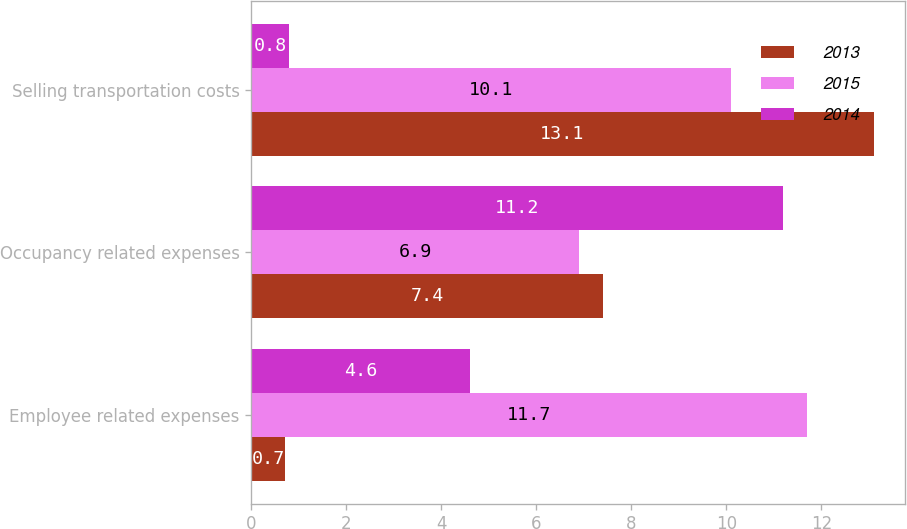Convert chart. <chart><loc_0><loc_0><loc_500><loc_500><stacked_bar_chart><ecel><fcel>Employee related expenses<fcel>Occupancy related expenses<fcel>Selling transportation costs<nl><fcel>2013<fcel>0.7<fcel>7.4<fcel>13.1<nl><fcel>2015<fcel>11.7<fcel>6.9<fcel>10.1<nl><fcel>2014<fcel>4.6<fcel>11.2<fcel>0.8<nl></chart> 